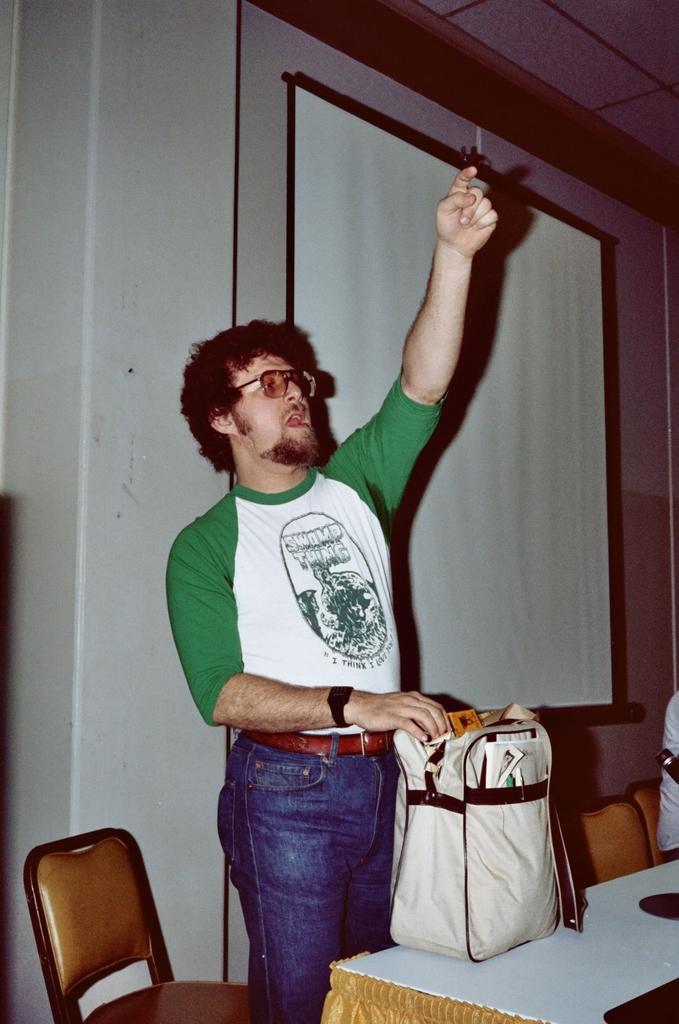Describe this image in one or two sentences. In this image i can see a man standing holding a bag on the table at the back ground i can see a chair, a screen and a wall. 